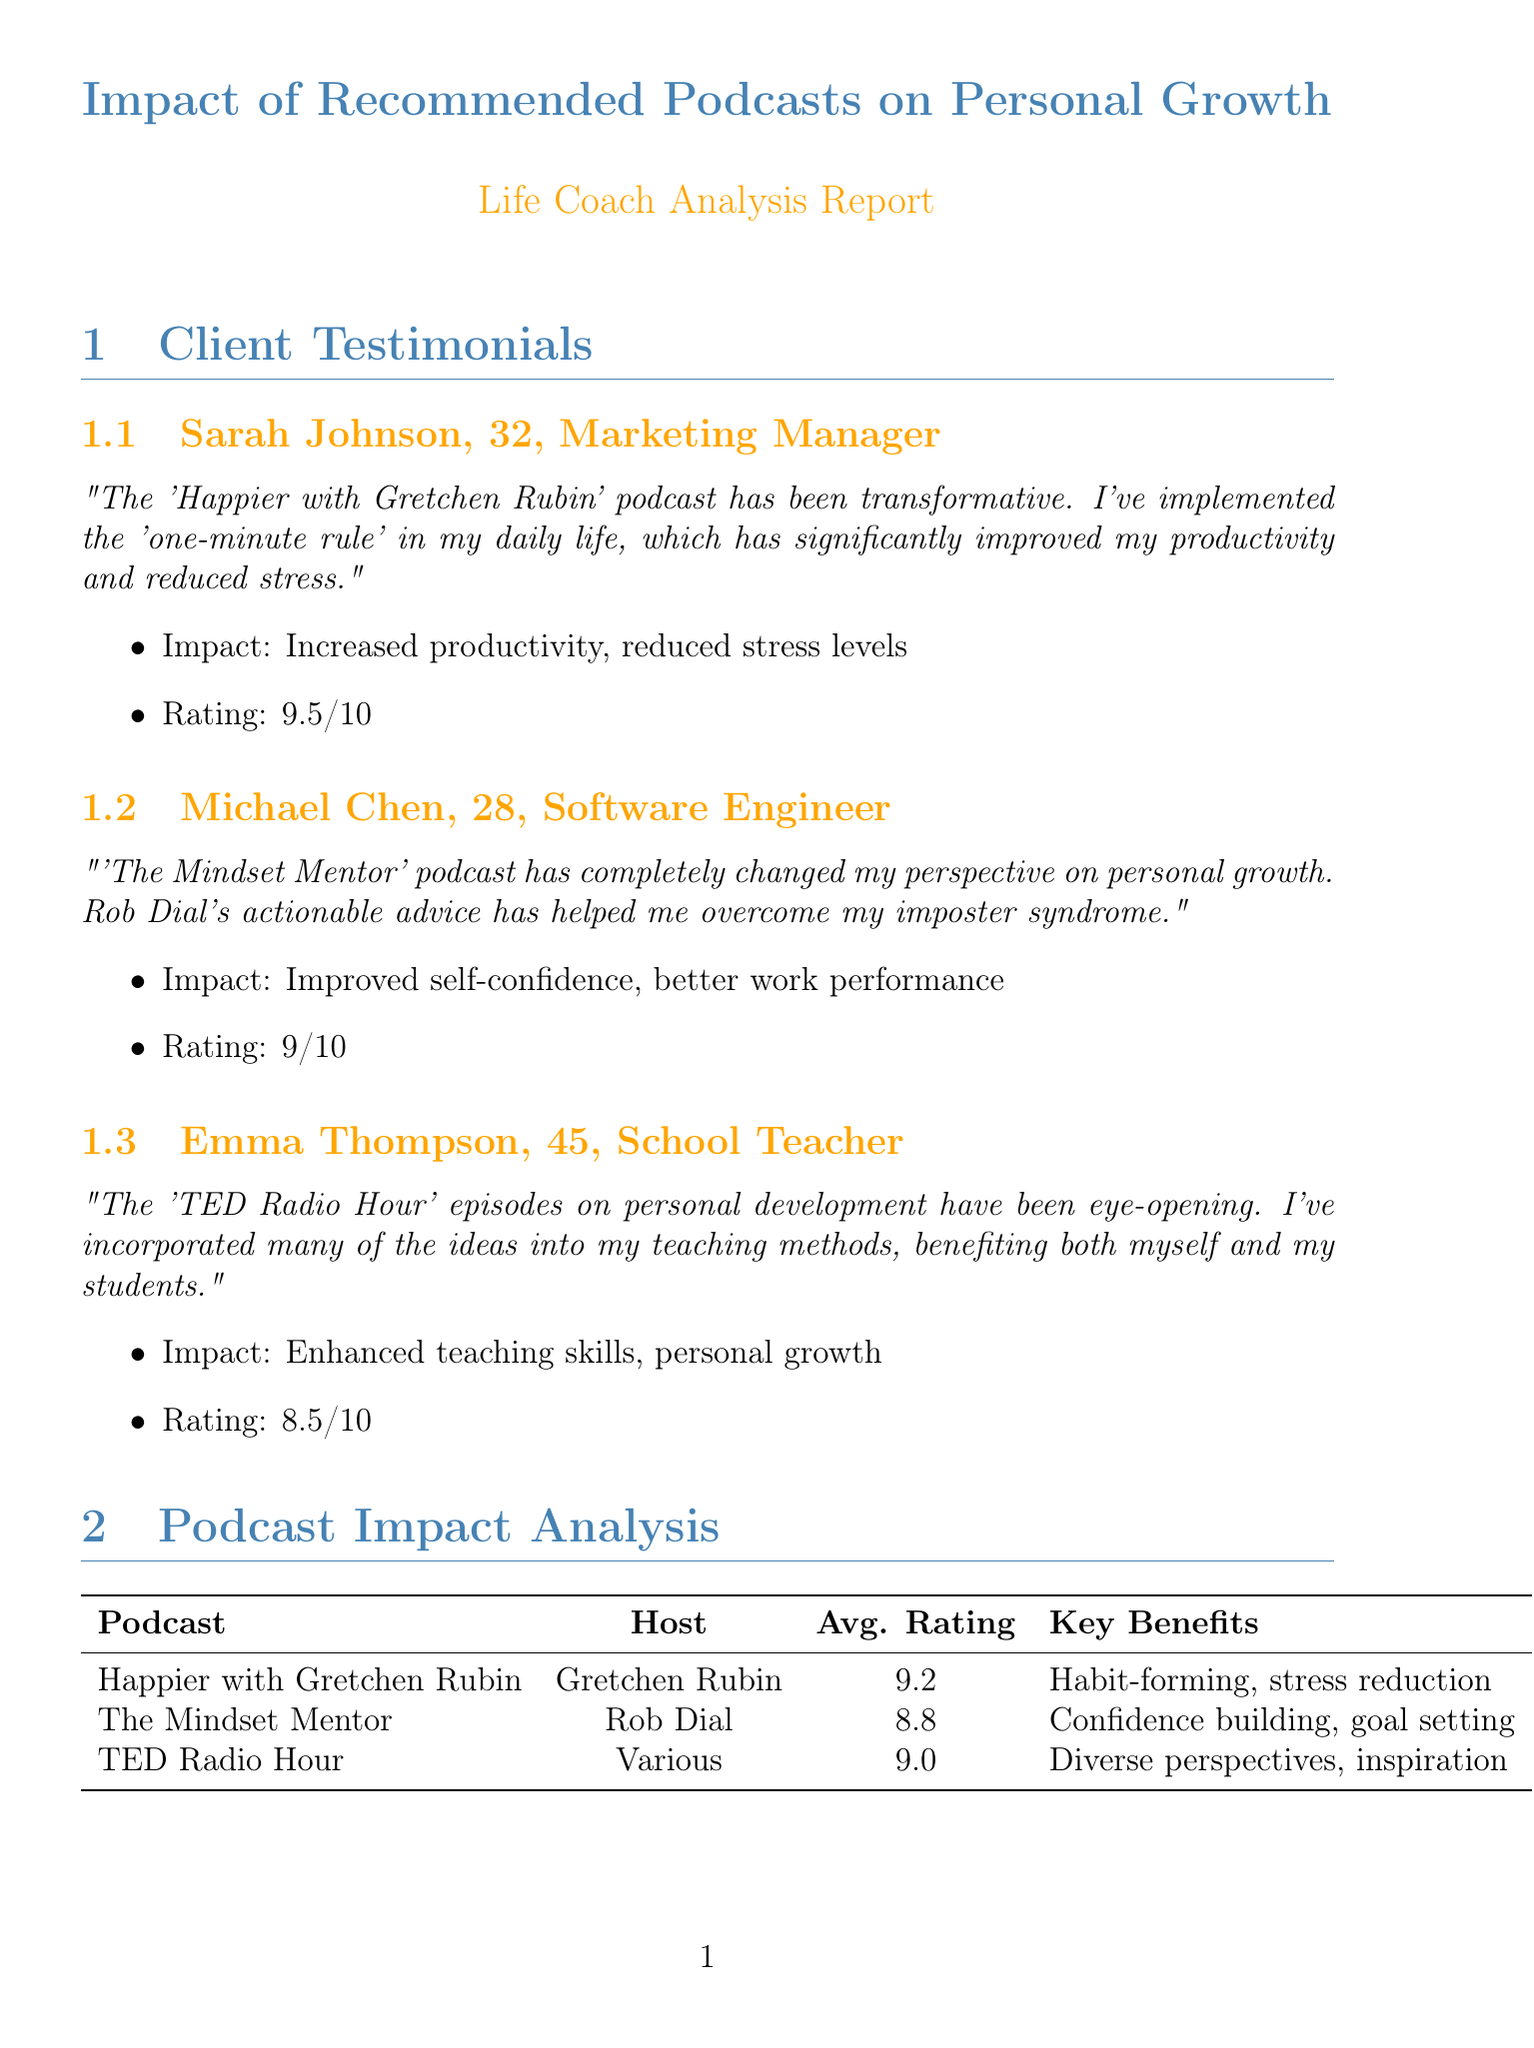What is the name of the podcast recommended to Sarah Johnson? Sarah Johnson recommends "Happier with Gretchen Rubin," which was suggested by her life coach.
Answer: Happier with Gretchen Rubin What is Michael Chen's rating for "The Mindset Mentor"? Michael Chen rated "The Mindset Mentor" podcast a 9 out of 10.
Answer: 9 What is the average rating for the "TED Radio Hour"? The document states that the average rating for "TED Radio Hour" is 9.
Answer: 9 What improvement percentage is reported for self-reported happiness levels? The average improvement for self-reported happiness levels is indicated as 32%.
Answer: 32% Which client mentioned improving their teaching skills? Emma Thompson mentioned that the podcast helped enhance her teaching skills.
Answer: Emma Thompson What are the top professions represented in the client demographic data? The top professions include Marketing, Technology, Education, Healthcare, and Finance.
Answer: Marketing, Technology, Education, Healthcare, Finance What is the key benefit of the "Mindset Mentor" podcast? One key benefit mentioned is "Confidence building."
Answer: Confidence building How often are the follow-up processes scheduled? The follow-up processes involve bi-weekly check-ins.
Answer: Bi-weekly Which episode is mentioned as most impactful for "Happier with Gretchen Rubin"? "The One-Minute Rule" is highlighted as a most impactful episode.
Answer: The One-Minute Rule 